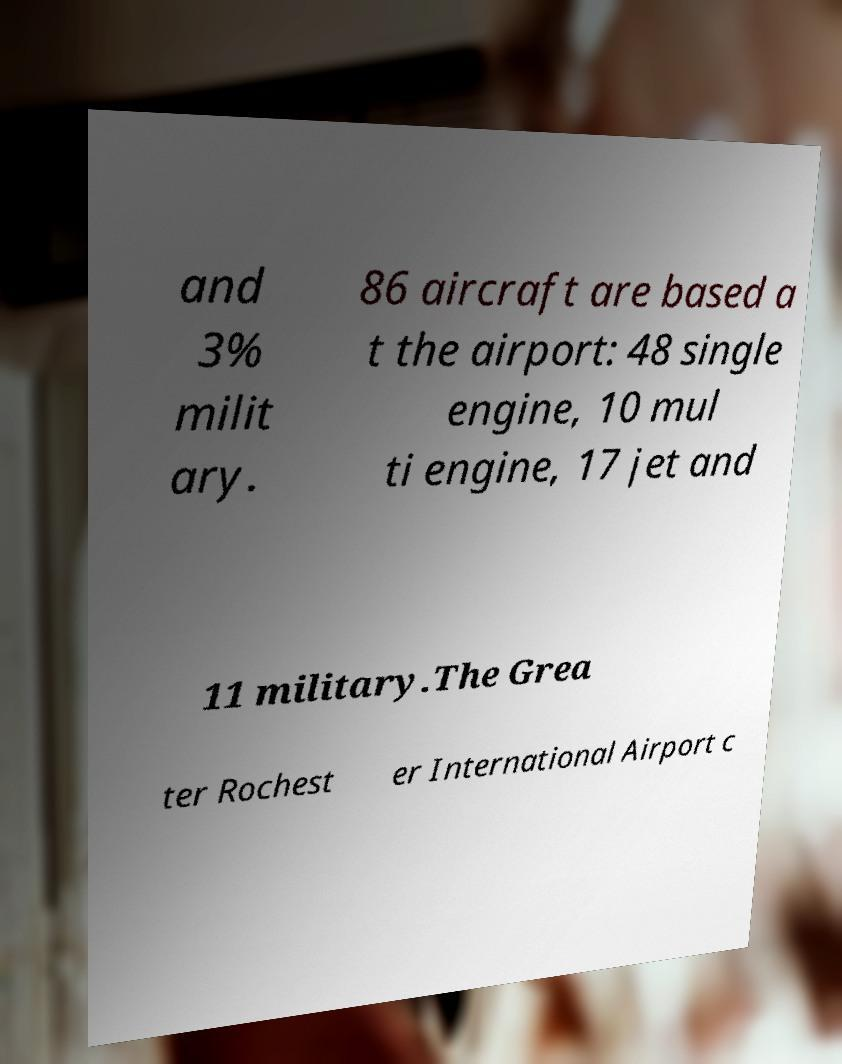For documentation purposes, I need the text within this image transcribed. Could you provide that? and 3% milit ary. 86 aircraft are based a t the airport: 48 single engine, 10 mul ti engine, 17 jet and 11 military.The Grea ter Rochest er International Airport c 